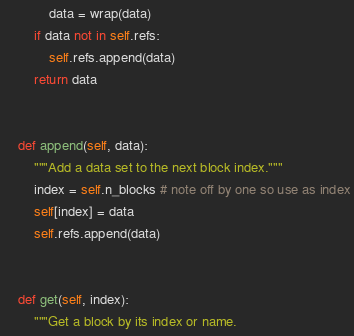Convert code to text. <code><loc_0><loc_0><loc_500><loc_500><_Python_>            data = wrap(data)
        if data not in self.refs:
            self.refs.append(data)
        return data


    def append(self, data):
        """Add a data set to the next block index."""
        index = self.n_blocks # note off by one so use as index
        self[index] = data
        self.refs.append(data)


    def get(self, index):
        """Get a block by its index or name.
</code> 